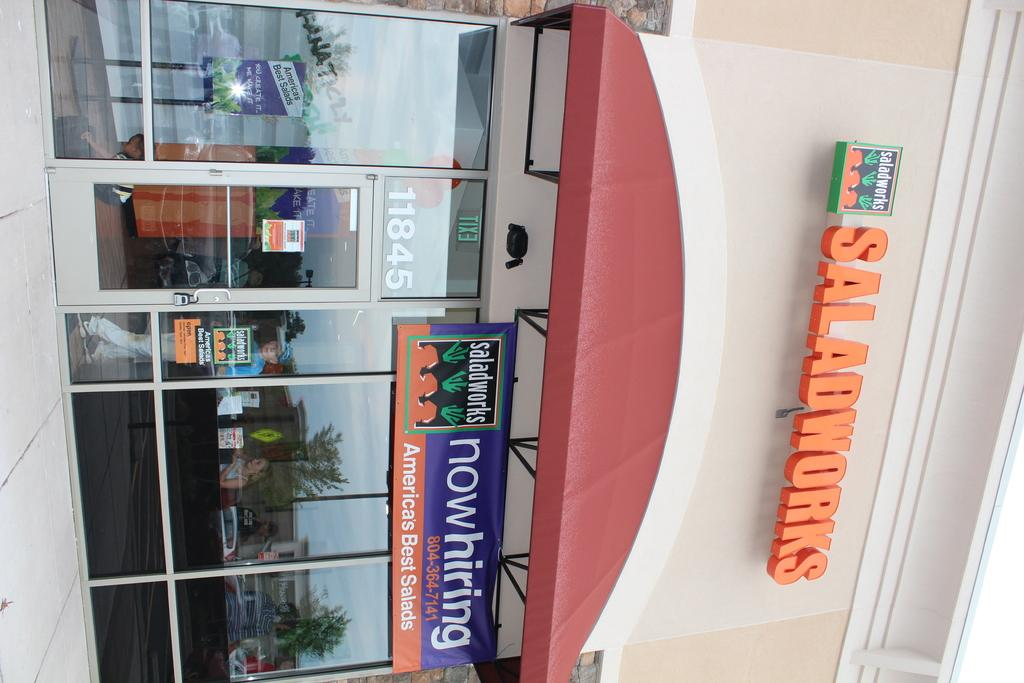What type of structure is visible in the image? There is a building in the image. What is unique about the walls of the building? The building has glass walls. How can people enter or exit the building? The building has a door. What is attached to the building? There is a board on the building. What is written on the board, and what color is the text? The word 'saladworks' is written on the board in orange color. How many wrens are nesting in the beds inside the building in the image? There are no wrens or beds present in the image; it features a building with a board displaying the word 'saladworks'. 